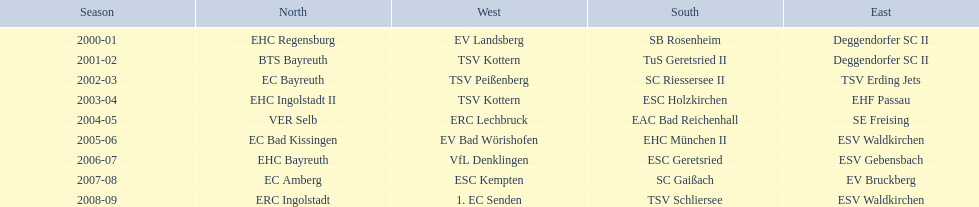Which teams won the north in their respective years? 2000-01, EHC Regensburg, BTS Bayreuth, EC Bayreuth, EHC Ingolstadt II, VER Selb, EC Bad Kissingen, EHC Bayreuth, EC Amberg, ERC Ingolstadt. Which one only won in 2000-01? EHC Regensburg. 